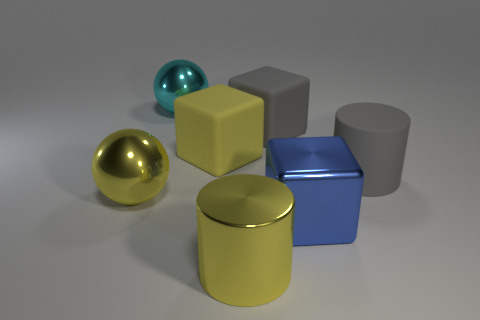Subtract all gray blocks. Subtract all blue cylinders. How many blocks are left? 2 Add 2 large blue shiny spheres. How many objects exist? 9 Subtract all balls. How many objects are left? 5 Add 3 large metallic cylinders. How many large metallic cylinders exist? 4 Subtract 0 purple cylinders. How many objects are left? 7 Subtract all yellow metal cylinders. Subtract all large gray cylinders. How many objects are left? 5 Add 3 big shiny spheres. How many big shiny spheres are left? 5 